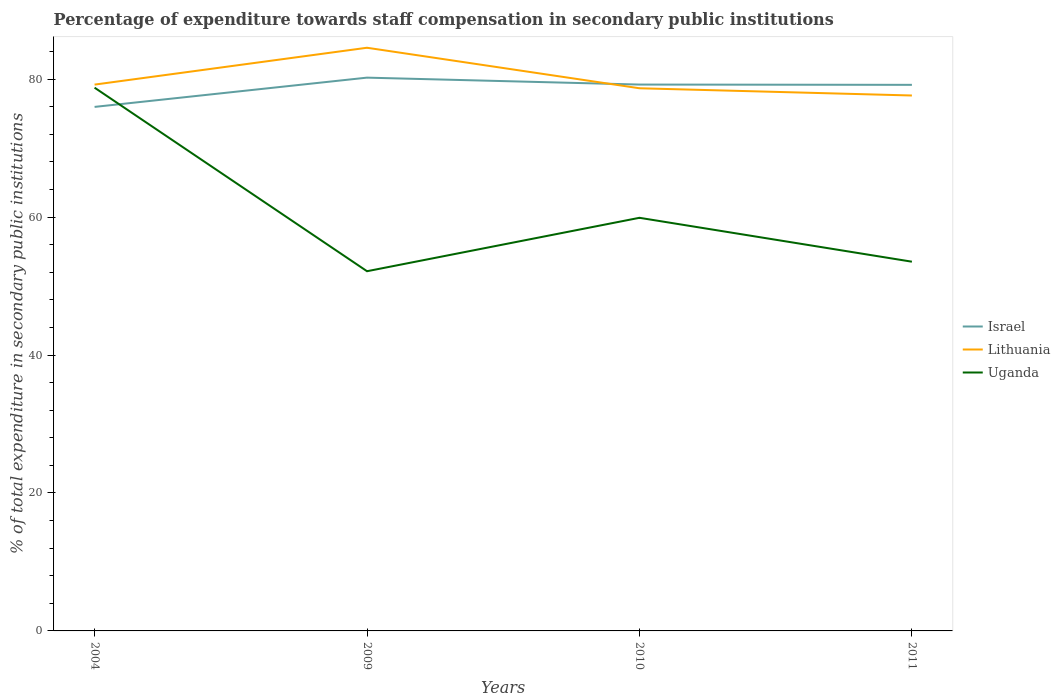How many different coloured lines are there?
Your answer should be very brief. 3. Does the line corresponding to Uganda intersect with the line corresponding to Lithuania?
Provide a succinct answer. No. Across all years, what is the maximum percentage of expenditure towards staff compensation in Uganda?
Make the answer very short. 52.15. In which year was the percentage of expenditure towards staff compensation in Israel maximum?
Your answer should be very brief. 2004. What is the total percentage of expenditure towards staff compensation in Israel in the graph?
Provide a short and direct response. -3.24. What is the difference between the highest and the second highest percentage of expenditure towards staff compensation in Lithuania?
Give a very brief answer. 6.92. What is the difference between the highest and the lowest percentage of expenditure towards staff compensation in Uganda?
Give a very brief answer. 1. How many years are there in the graph?
Ensure brevity in your answer.  4. Are the values on the major ticks of Y-axis written in scientific E-notation?
Provide a succinct answer. No. Does the graph contain any zero values?
Your response must be concise. No. Where does the legend appear in the graph?
Provide a short and direct response. Center right. How many legend labels are there?
Your answer should be compact. 3. What is the title of the graph?
Give a very brief answer. Percentage of expenditure towards staff compensation in secondary public institutions. What is the label or title of the X-axis?
Make the answer very short. Years. What is the label or title of the Y-axis?
Give a very brief answer. % of total expenditure in secondary public institutions. What is the % of total expenditure in secondary public institutions in Israel in 2004?
Make the answer very short. 75.97. What is the % of total expenditure in secondary public institutions in Lithuania in 2004?
Provide a succinct answer. 79.21. What is the % of total expenditure in secondary public institutions of Uganda in 2004?
Offer a terse response. 78.76. What is the % of total expenditure in secondary public institutions in Israel in 2009?
Give a very brief answer. 80.22. What is the % of total expenditure in secondary public institutions of Lithuania in 2009?
Provide a short and direct response. 84.55. What is the % of total expenditure in secondary public institutions in Uganda in 2009?
Your response must be concise. 52.15. What is the % of total expenditure in secondary public institutions in Israel in 2010?
Provide a short and direct response. 79.21. What is the % of total expenditure in secondary public institutions of Lithuania in 2010?
Ensure brevity in your answer.  78.68. What is the % of total expenditure in secondary public institutions of Uganda in 2010?
Ensure brevity in your answer.  59.9. What is the % of total expenditure in secondary public institutions of Israel in 2011?
Offer a terse response. 79.17. What is the % of total expenditure in secondary public institutions in Lithuania in 2011?
Your answer should be compact. 77.63. What is the % of total expenditure in secondary public institutions in Uganda in 2011?
Ensure brevity in your answer.  53.53. Across all years, what is the maximum % of total expenditure in secondary public institutions of Israel?
Your answer should be very brief. 80.22. Across all years, what is the maximum % of total expenditure in secondary public institutions of Lithuania?
Offer a terse response. 84.55. Across all years, what is the maximum % of total expenditure in secondary public institutions of Uganda?
Your answer should be very brief. 78.76. Across all years, what is the minimum % of total expenditure in secondary public institutions of Israel?
Offer a very short reply. 75.97. Across all years, what is the minimum % of total expenditure in secondary public institutions in Lithuania?
Provide a succinct answer. 77.63. Across all years, what is the minimum % of total expenditure in secondary public institutions of Uganda?
Ensure brevity in your answer.  52.15. What is the total % of total expenditure in secondary public institutions of Israel in the graph?
Give a very brief answer. 314.58. What is the total % of total expenditure in secondary public institutions of Lithuania in the graph?
Your answer should be compact. 320.06. What is the total % of total expenditure in secondary public institutions in Uganda in the graph?
Your answer should be compact. 244.34. What is the difference between the % of total expenditure in secondary public institutions in Israel in 2004 and that in 2009?
Provide a succinct answer. -4.24. What is the difference between the % of total expenditure in secondary public institutions of Lithuania in 2004 and that in 2009?
Make the answer very short. -5.34. What is the difference between the % of total expenditure in secondary public institutions in Uganda in 2004 and that in 2009?
Provide a succinct answer. 26.61. What is the difference between the % of total expenditure in secondary public institutions of Israel in 2004 and that in 2010?
Make the answer very short. -3.24. What is the difference between the % of total expenditure in secondary public institutions in Lithuania in 2004 and that in 2010?
Make the answer very short. 0.53. What is the difference between the % of total expenditure in secondary public institutions of Uganda in 2004 and that in 2010?
Make the answer very short. 18.87. What is the difference between the % of total expenditure in secondary public institutions of Israel in 2004 and that in 2011?
Give a very brief answer. -3.2. What is the difference between the % of total expenditure in secondary public institutions in Lithuania in 2004 and that in 2011?
Offer a terse response. 1.58. What is the difference between the % of total expenditure in secondary public institutions of Uganda in 2004 and that in 2011?
Ensure brevity in your answer.  25.23. What is the difference between the % of total expenditure in secondary public institutions of Israel in 2009 and that in 2010?
Your response must be concise. 1. What is the difference between the % of total expenditure in secondary public institutions of Lithuania in 2009 and that in 2010?
Offer a terse response. 5.87. What is the difference between the % of total expenditure in secondary public institutions of Uganda in 2009 and that in 2010?
Provide a succinct answer. -7.75. What is the difference between the % of total expenditure in secondary public institutions in Israel in 2009 and that in 2011?
Make the answer very short. 1.04. What is the difference between the % of total expenditure in secondary public institutions in Lithuania in 2009 and that in 2011?
Give a very brief answer. 6.92. What is the difference between the % of total expenditure in secondary public institutions of Uganda in 2009 and that in 2011?
Give a very brief answer. -1.38. What is the difference between the % of total expenditure in secondary public institutions in Israel in 2010 and that in 2011?
Offer a terse response. 0.04. What is the difference between the % of total expenditure in secondary public institutions of Lithuania in 2010 and that in 2011?
Offer a terse response. 1.05. What is the difference between the % of total expenditure in secondary public institutions of Uganda in 2010 and that in 2011?
Offer a terse response. 6.36. What is the difference between the % of total expenditure in secondary public institutions in Israel in 2004 and the % of total expenditure in secondary public institutions in Lithuania in 2009?
Your answer should be compact. -8.58. What is the difference between the % of total expenditure in secondary public institutions in Israel in 2004 and the % of total expenditure in secondary public institutions in Uganda in 2009?
Your answer should be very brief. 23.82. What is the difference between the % of total expenditure in secondary public institutions of Lithuania in 2004 and the % of total expenditure in secondary public institutions of Uganda in 2009?
Make the answer very short. 27.06. What is the difference between the % of total expenditure in secondary public institutions of Israel in 2004 and the % of total expenditure in secondary public institutions of Lithuania in 2010?
Your response must be concise. -2.7. What is the difference between the % of total expenditure in secondary public institutions in Israel in 2004 and the % of total expenditure in secondary public institutions in Uganda in 2010?
Your response must be concise. 16.08. What is the difference between the % of total expenditure in secondary public institutions in Lithuania in 2004 and the % of total expenditure in secondary public institutions in Uganda in 2010?
Your answer should be compact. 19.31. What is the difference between the % of total expenditure in secondary public institutions of Israel in 2004 and the % of total expenditure in secondary public institutions of Lithuania in 2011?
Offer a terse response. -1.65. What is the difference between the % of total expenditure in secondary public institutions in Israel in 2004 and the % of total expenditure in secondary public institutions in Uganda in 2011?
Offer a very short reply. 22.44. What is the difference between the % of total expenditure in secondary public institutions in Lithuania in 2004 and the % of total expenditure in secondary public institutions in Uganda in 2011?
Provide a succinct answer. 25.68. What is the difference between the % of total expenditure in secondary public institutions of Israel in 2009 and the % of total expenditure in secondary public institutions of Lithuania in 2010?
Your answer should be compact. 1.54. What is the difference between the % of total expenditure in secondary public institutions in Israel in 2009 and the % of total expenditure in secondary public institutions in Uganda in 2010?
Offer a very short reply. 20.32. What is the difference between the % of total expenditure in secondary public institutions in Lithuania in 2009 and the % of total expenditure in secondary public institutions in Uganda in 2010?
Ensure brevity in your answer.  24.65. What is the difference between the % of total expenditure in secondary public institutions in Israel in 2009 and the % of total expenditure in secondary public institutions in Lithuania in 2011?
Offer a terse response. 2.59. What is the difference between the % of total expenditure in secondary public institutions of Israel in 2009 and the % of total expenditure in secondary public institutions of Uganda in 2011?
Your response must be concise. 26.69. What is the difference between the % of total expenditure in secondary public institutions of Lithuania in 2009 and the % of total expenditure in secondary public institutions of Uganda in 2011?
Offer a very short reply. 31.02. What is the difference between the % of total expenditure in secondary public institutions in Israel in 2010 and the % of total expenditure in secondary public institutions in Lithuania in 2011?
Offer a terse response. 1.58. What is the difference between the % of total expenditure in secondary public institutions in Israel in 2010 and the % of total expenditure in secondary public institutions in Uganda in 2011?
Offer a very short reply. 25.68. What is the difference between the % of total expenditure in secondary public institutions of Lithuania in 2010 and the % of total expenditure in secondary public institutions of Uganda in 2011?
Your response must be concise. 25.14. What is the average % of total expenditure in secondary public institutions in Israel per year?
Provide a succinct answer. 78.64. What is the average % of total expenditure in secondary public institutions of Lithuania per year?
Offer a terse response. 80.02. What is the average % of total expenditure in secondary public institutions of Uganda per year?
Provide a succinct answer. 61.09. In the year 2004, what is the difference between the % of total expenditure in secondary public institutions of Israel and % of total expenditure in secondary public institutions of Lithuania?
Offer a very short reply. -3.23. In the year 2004, what is the difference between the % of total expenditure in secondary public institutions of Israel and % of total expenditure in secondary public institutions of Uganda?
Keep it short and to the point. -2.79. In the year 2004, what is the difference between the % of total expenditure in secondary public institutions in Lithuania and % of total expenditure in secondary public institutions in Uganda?
Ensure brevity in your answer.  0.45. In the year 2009, what is the difference between the % of total expenditure in secondary public institutions of Israel and % of total expenditure in secondary public institutions of Lithuania?
Your response must be concise. -4.33. In the year 2009, what is the difference between the % of total expenditure in secondary public institutions in Israel and % of total expenditure in secondary public institutions in Uganda?
Keep it short and to the point. 28.07. In the year 2009, what is the difference between the % of total expenditure in secondary public institutions in Lithuania and % of total expenditure in secondary public institutions in Uganda?
Your answer should be compact. 32.4. In the year 2010, what is the difference between the % of total expenditure in secondary public institutions in Israel and % of total expenditure in secondary public institutions in Lithuania?
Keep it short and to the point. 0.54. In the year 2010, what is the difference between the % of total expenditure in secondary public institutions in Israel and % of total expenditure in secondary public institutions in Uganda?
Make the answer very short. 19.32. In the year 2010, what is the difference between the % of total expenditure in secondary public institutions of Lithuania and % of total expenditure in secondary public institutions of Uganda?
Offer a terse response. 18.78. In the year 2011, what is the difference between the % of total expenditure in secondary public institutions of Israel and % of total expenditure in secondary public institutions of Lithuania?
Keep it short and to the point. 1.55. In the year 2011, what is the difference between the % of total expenditure in secondary public institutions in Israel and % of total expenditure in secondary public institutions in Uganda?
Ensure brevity in your answer.  25.64. In the year 2011, what is the difference between the % of total expenditure in secondary public institutions of Lithuania and % of total expenditure in secondary public institutions of Uganda?
Make the answer very short. 24.1. What is the ratio of the % of total expenditure in secondary public institutions in Israel in 2004 to that in 2009?
Offer a very short reply. 0.95. What is the ratio of the % of total expenditure in secondary public institutions of Lithuania in 2004 to that in 2009?
Your answer should be compact. 0.94. What is the ratio of the % of total expenditure in secondary public institutions in Uganda in 2004 to that in 2009?
Your answer should be compact. 1.51. What is the ratio of the % of total expenditure in secondary public institutions of Israel in 2004 to that in 2010?
Make the answer very short. 0.96. What is the ratio of the % of total expenditure in secondary public institutions in Lithuania in 2004 to that in 2010?
Make the answer very short. 1.01. What is the ratio of the % of total expenditure in secondary public institutions in Uganda in 2004 to that in 2010?
Provide a short and direct response. 1.31. What is the ratio of the % of total expenditure in secondary public institutions in Israel in 2004 to that in 2011?
Make the answer very short. 0.96. What is the ratio of the % of total expenditure in secondary public institutions in Lithuania in 2004 to that in 2011?
Give a very brief answer. 1.02. What is the ratio of the % of total expenditure in secondary public institutions of Uganda in 2004 to that in 2011?
Make the answer very short. 1.47. What is the ratio of the % of total expenditure in secondary public institutions of Israel in 2009 to that in 2010?
Offer a terse response. 1.01. What is the ratio of the % of total expenditure in secondary public institutions of Lithuania in 2009 to that in 2010?
Offer a terse response. 1.07. What is the ratio of the % of total expenditure in secondary public institutions of Uganda in 2009 to that in 2010?
Give a very brief answer. 0.87. What is the ratio of the % of total expenditure in secondary public institutions in Israel in 2009 to that in 2011?
Your answer should be very brief. 1.01. What is the ratio of the % of total expenditure in secondary public institutions in Lithuania in 2009 to that in 2011?
Keep it short and to the point. 1.09. What is the ratio of the % of total expenditure in secondary public institutions in Uganda in 2009 to that in 2011?
Your answer should be compact. 0.97. What is the ratio of the % of total expenditure in secondary public institutions of Lithuania in 2010 to that in 2011?
Ensure brevity in your answer.  1.01. What is the ratio of the % of total expenditure in secondary public institutions in Uganda in 2010 to that in 2011?
Your answer should be compact. 1.12. What is the difference between the highest and the second highest % of total expenditure in secondary public institutions in Israel?
Keep it short and to the point. 1. What is the difference between the highest and the second highest % of total expenditure in secondary public institutions of Lithuania?
Your answer should be compact. 5.34. What is the difference between the highest and the second highest % of total expenditure in secondary public institutions of Uganda?
Make the answer very short. 18.87. What is the difference between the highest and the lowest % of total expenditure in secondary public institutions of Israel?
Your response must be concise. 4.24. What is the difference between the highest and the lowest % of total expenditure in secondary public institutions of Lithuania?
Make the answer very short. 6.92. What is the difference between the highest and the lowest % of total expenditure in secondary public institutions of Uganda?
Ensure brevity in your answer.  26.61. 